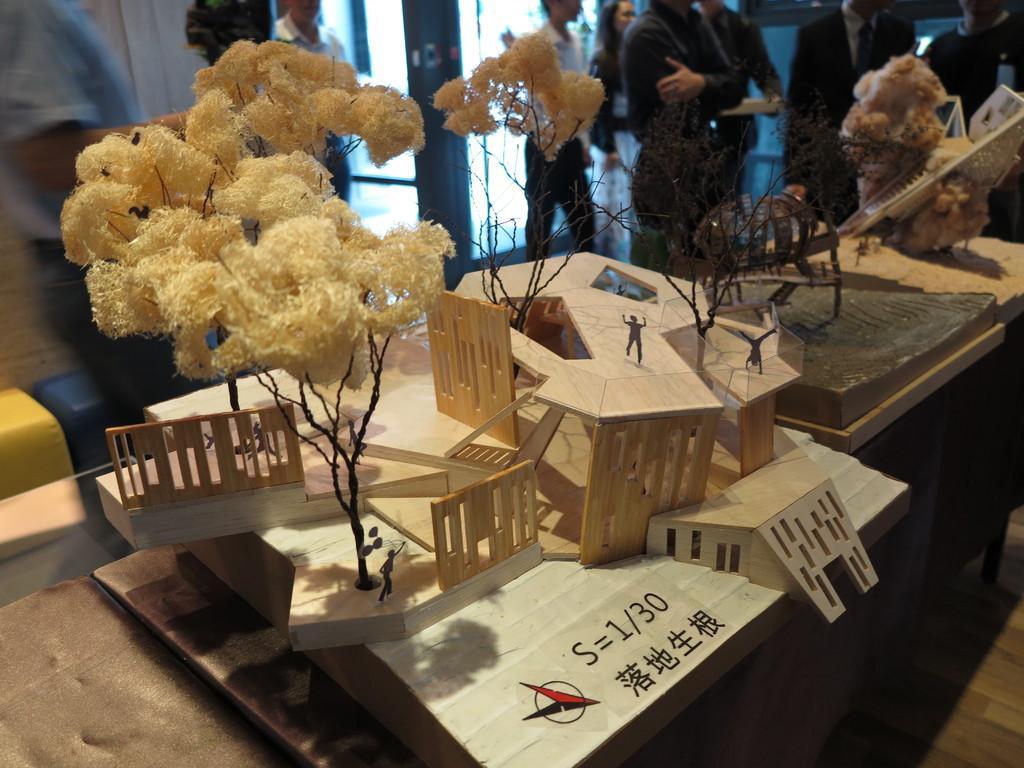Please provide a concise description of this image. Here on the table there are some fine arts like a tree people are standing on the roof of building. Behind the table there are some people standing. And we can also see a door. 